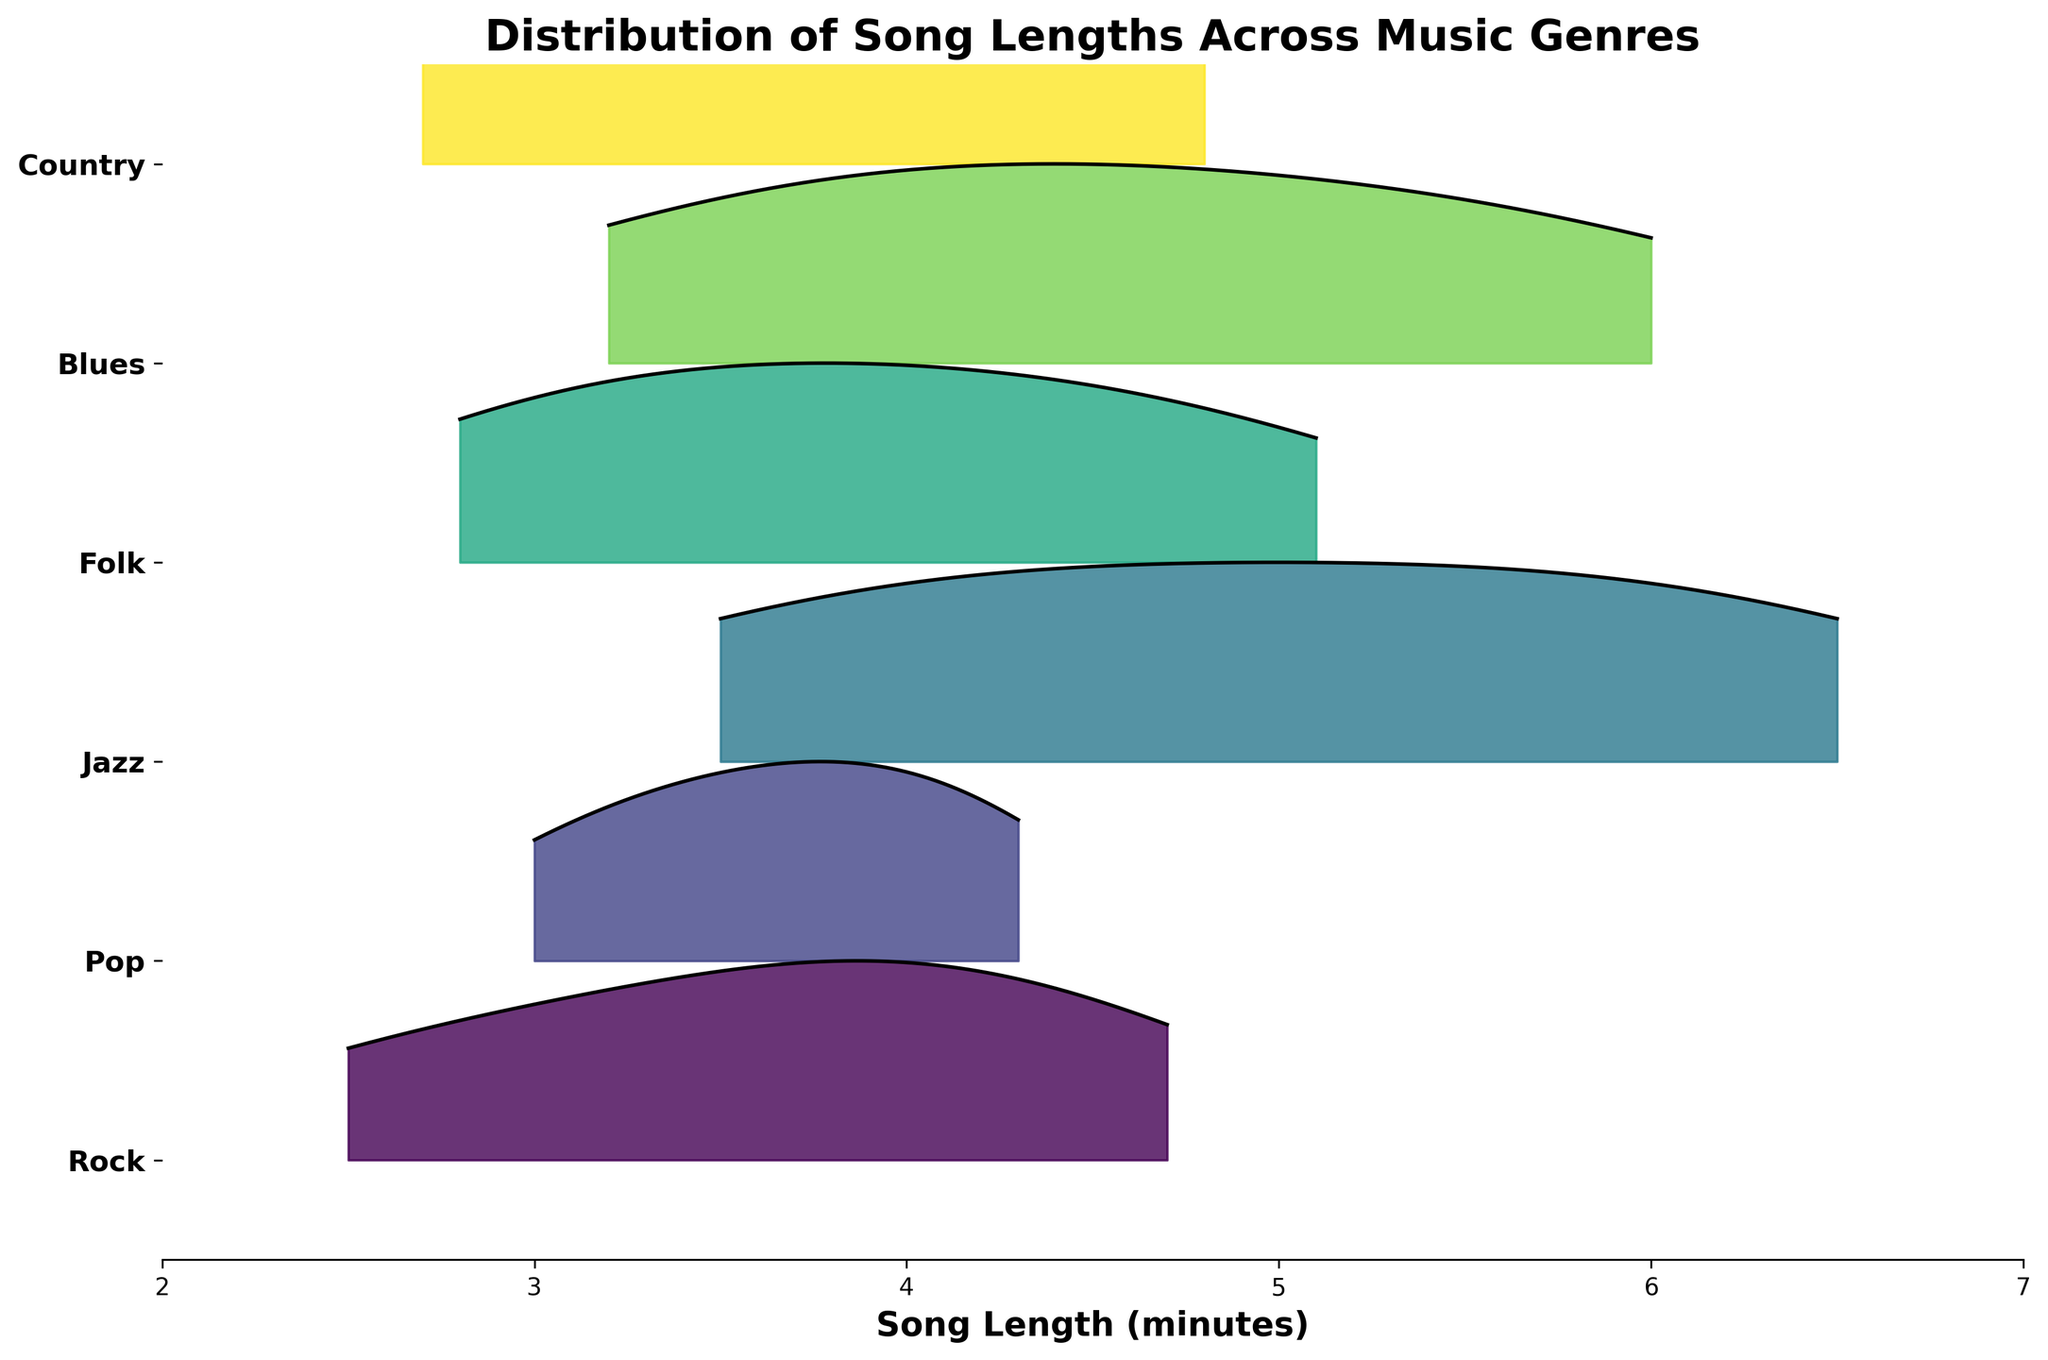What is the title of the plot? The title of the plot is typically located at the top, centered above the actual data visualization. It summarises the main theme of the plot.
Answer: Distribution of Song Lengths Across Music Genres Which genre has the longest maximum song length? Observing the distribution curves, the genre with the longest spread towards the right will have the longest maximum song length.
Answer: Jazz Which genre has the shortest minimum song length? Look for the genre whose distribution curve starts furthest to the left.
Answer: Rock How many genres are represented in the plot? Count the number of unique horizontal sections representing different genres.
Answer: Six What is the song length range for Blues? Determine the spread from the minimum to the maximum point on the distribution curve for Blues.
Answer: 3.2 to 6.0 minutes Which genre has the most varied song length distribution? The genre with the widest spread in its distribution curve indicates the most varied song length.
Answer: Jazz Is the median song length for Folk greater than 4 minutes? Identify the midpoint of the distribution curve for the Folk genre to determine if it's above 4 minutes.
Answer: Yes Which genre has the most concentrated distribution around its mean? The genre with the tallest peak in its distribution curve, indicating less variance around the mean, is the one to look for.
Answer: Rock Comparing Pop and Country, which genre has the longer median song length? Find the midpoint of each distribution and compare them. The genre whose median lies further to the right will have the longer median song length.
Answer: Pop Is there any overlap between the song lengths of Jazz and Country? Check the x-axis range covered by the Jazz and Country distributions to see if there is any common x-value range where both distributions overlap.
Answer: Yes 